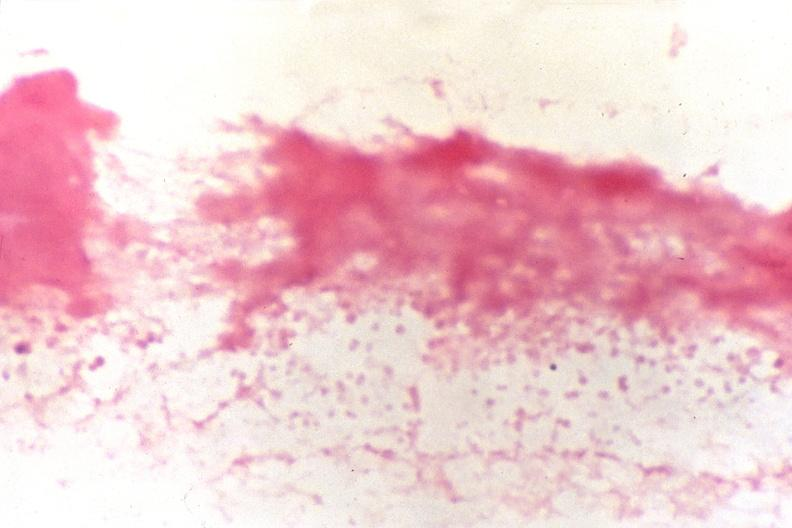does gram negative cocci, neisseria meningitidis, gram stain?
Answer the question using a single word or phrase. Yes 